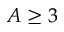Convert formula to latex. <formula><loc_0><loc_0><loc_500><loc_500>A \geq 3</formula> 